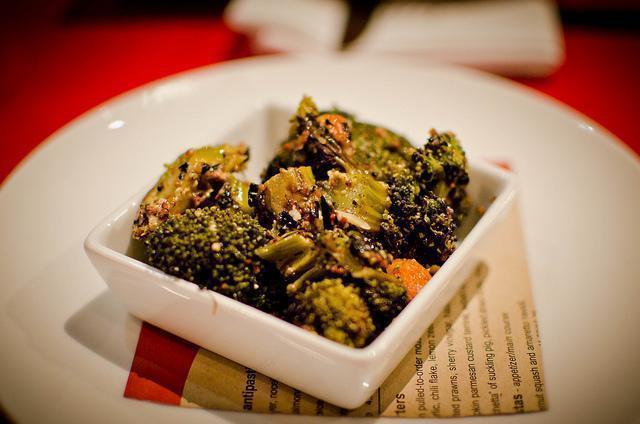What shape is the small plate?
Select the accurate answer and provide justification: `Answer: choice
Rationale: srationale.`
Options: Circle, octagon, square, hexagon. Answer: square.
Rationale: The shape is a square. 